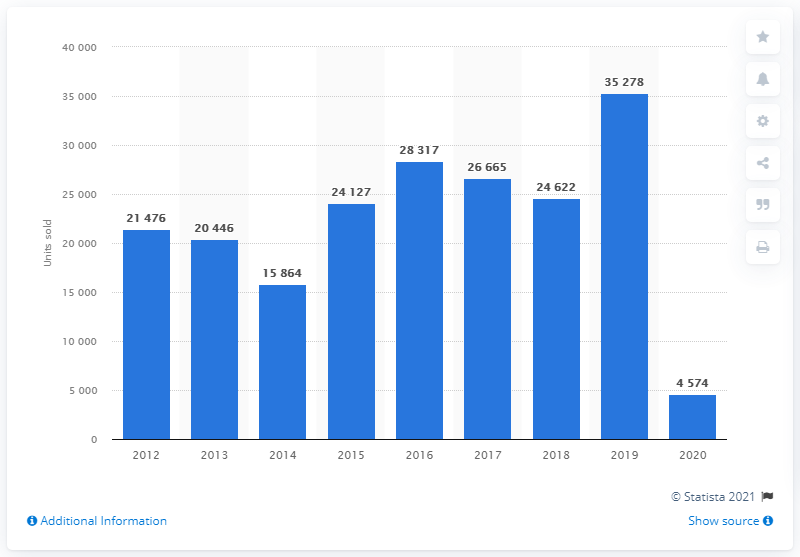List a handful of essential elements in this visual. In the year 2020, Smart recorded its lowest sales figures in a decade. 